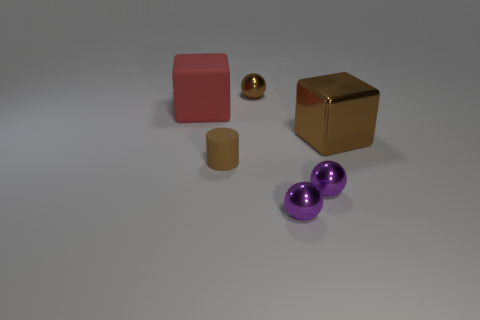What number of things are big things left of the small rubber cylinder or brown metallic things on the right side of the brown shiny sphere? There are three large objects to the left of the small rubber cylinder: a red cube, a golden cube, and two purple shiny spheres. On the right side of the brown shiny sphere, there is one large brown metallic cube. So, in total, there are four big objects in the specified positions relative to the small cylinder and shiny sphere. 